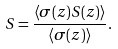<formula> <loc_0><loc_0><loc_500><loc_500>S = \frac { \left \langle \sigma ( z ) S ( z ) \right \rangle } { \left \langle \sigma ( z ) \right \rangle } .</formula> 